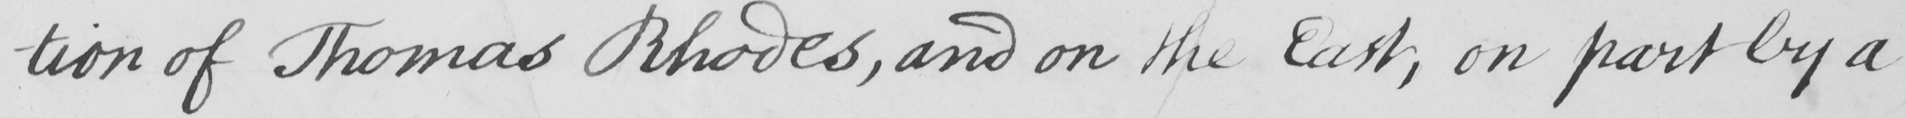Can you tell me what this handwritten text says? -tion of Thomas Rhodes , and on the East , on part by a 